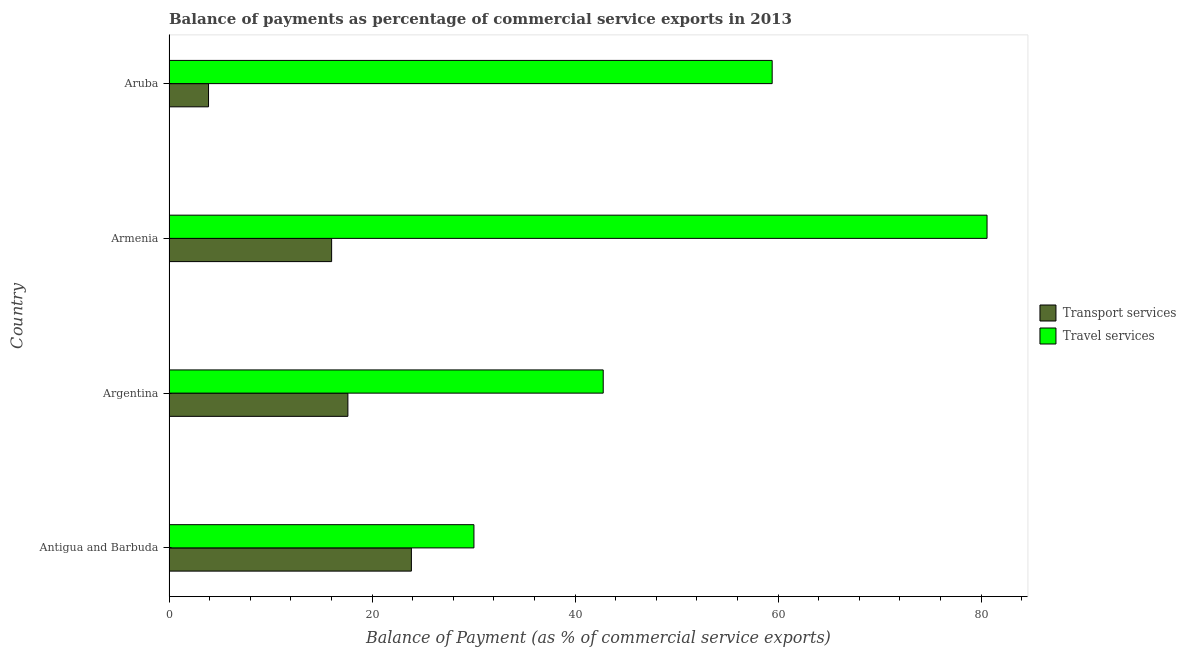Are the number of bars per tick equal to the number of legend labels?
Keep it short and to the point. Yes. Are the number of bars on each tick of the Y-axis equal?
Make the answer very short. Yes. What is the label of the 4th group of bars from the top?
Offer a very short reply. Antigua and Barbuda. What is the balance of payments of travel services in Aruba?
Offer a very short reply. 59.42. Across all countries, what is the maximum balance of payments of travel services?
Offer a terse response. 80.59. Across all countries, what is the minimum balance of payments of transport services?
Your answer should be very brief. 3.89. In which country was the balance of payments of transport services maximum?
Ensure brevity in your answer.  Antigua and Barbuda. In which country was the balance of payments of transport services minimum?
Make the answer very short. Aruba. What is the total balance of payments of travel services in the graph?
Offer a very short reply. 212.82. What is the difference between the balance of payments of travel services in Argentina and that in Aruba?
Provide a succinct answer. -16.64. What is the difference between the balance of payments of travel services in Argentina and the balance of payments of transport services in Armenia?
Provide a short and direct response. 26.75. What is the average balance of payments of travel services per country?
Offer a terse response. 53.2. What is the difference between the balance of payments of travel services and balance of payments of transport services in Antigua and Barbuda?
Give a very brief answer. 6.16. In how many countries, is the balance of payments of transport services greater than 48 %?
Provide a short and direct response. 0. What is the ratio of the balance of payments of transport services in Armenia to that in Aruba?
Provide a succinct answer. 4.11. Is the balance of payments of transport services in Armenia less than that in Aruba?
Give a very brief answer. No. Is the difference between the balance of payments of travel services in Argentina and Armenia greater than the difference between the balance of payments of transport services in Argentina and Armenia?
Make the answer very short. No. What is the difference between the highest and the second highest balance of payments of transport services?
Provide a short and direct response. 6.26. What is the difference between the highest and the lowest balance of payments of travel services?
Your response must be concise. 50.55. What does the 2nd bar from the top in Antigua and Barbuda represents?
Offer a very short reply. Transport services. What does the 2nd bar from the bottom in Aruba represents?
Your answer should be very brief. Travel services. How many bars are there?
Ensure brevity in your answer.  8. What is the difference between two consecutive major ticks on the X-axis?
Provide a short and direct response. 20. Are the values on the major ticks of X-axis written in scientific E-notation?
Provide a short and direct response. No. How are the legend labels stacked?
Provide a succinct answer. Vertical. What is the title of the graph?
Provide a succinct answer. Balance of payments as percentage of commercial service exports in 2013. Does "Birth rate" appear as one of the legend labels in the graph?
Your answer should be very brief. No. What is the label or title of the X-axis?
Keep it short and to the point. Balance of Payment (as % of commercial service exports). What is the label or title of the Y-axis?
Provide a succinct answer. Country. What is the Balance of Payment (as % of commercial service exports) of Transport services in Antigua and Barbuda?
Ensure brevity in your answer.  23.88. What is the Balance of Payment (as % of commercial service exports) of Travel services in Antigua and Barbuda?
Provide a short and direct response. 30.04. What is the Balance of Payment (as % of commercial service exports) in Transport services in Argentina?
Provide a short and direct response. 17.62. What is the Balance of Payment (as % of commercial service exports) in Travel services in Argentina?
Your response must be concise. 42.78. What is the Balance of Payment (as % of commercial service exports) in Transport services in Armenia?
Offer a terse response. 16.02. What is the Balance of Payment (as % of commercial service exports) in Travel services in Armenia?
Ensure brevity in your answer.  80.59. What is the Balance of Payment (as % of commercial service exports) in Transport services in Aruba?
Give a very brief answer. 3.89. What is the Balance of Payment (as % of commercial service exports) of Travel services in Aruba?
Keep it short and to the point. 59.42. Across all countries, what is the maximum Balance of Payment (as % of commercial service exports) of Transport services?
Offer a very short reply. 23.88. Across all countries, what is the maximum Balance of Payment (as % of commercial service exports) of Travel services?
Keep it short and to the point. 80.59. Across all countries, what is the minimum Balance of Payment (as % of commercial service exports) of Transport services?
Give a very brief answer. 3.89. Across all countries, what is the minimum Balance of Payment (as % of commercial service exports) in Travel services?
Offer a very short reply. 30.04. What is the total Balance of Payment (as % of commercial service exports) in Transport services in the graph?
Offer a terse response. 61.42. What is the total Balance of Payment (as % of commercial service exports) in Travel services in the graph?
Provide a succinct answer. 212.82. What is the difference between the Balance of Payment (as % of commercial service exports) of Transport services in Antigua and Barbuda and that in Argentina?
Give a very brief answer. 6.26. What is the difference between the Balance of Payment (as % of commercial service exports) in Travel services in Antigua and Barbuda and that in Argentina?
Give a very brief answer. -12.74. What is the difference between the Balance of Payment (as % of commercial service exports) in Transport services in Antigua and Barbuda and that in Armenia?
Ensure brevity in your answer.  7.86. What is the difference between the Balance of Payment (as % of commercial service exports) in Travel services in Antigua and Barbuda and that in Armenia?
Make the answer very short. -50.55. What is the difference between the Balance of Payment (as % of commercial service exports) in Transport services in Antigua and Barbuda and that in Aruba?
Provide a short and direct response. 19.98. What is the difference between the Balance of Payment (as % of commercial service exports) of Travel services in Antigua and Barbuda and that in Aruba?
Your response must be concise. -29.38. What is the difference between the Balance of Payment (as % of commercial service exports) of Transport services in Argentina and that in Armenia?
Give a very brief answer. 1.6. What is the difference between the Balance of Payment (as % of commercial service exports) of Travel services in Argentina and that in Armenia?
Your answer should be very brief. -37.81. What is the difference between the Balance of Payment (as % of commercial service exports) in Transport services in Argentina and that in Aruba?
Your response must be concise. 13.73. What is the difference between the Balance of Payment (as % of commercial service exports) in Travel services in Argentina and that in Aruba?
Your answer should be very brief. -16.64. What is the difference between the Balance of Payment (as % of commercial service exports) in Transport services in Armenia and that in Aruba?
Ensure brevity in your answer.  12.13. What is the difference between the Balance of Payment (as % of commercial service exports) in Travel services in Armenia and that in Aruba?
Provide a succinct answer. 21.17. What is the difference between the Balance of Payment (as % of commercial service exports) of Transport services in Antigua and Barbuda and the Balance of Payment (as % of commercial service exports) of Travel services in Argentina?
Provide a succinct answer. -18.9. What is the difference between the Balance of Payment (as % of commercial service exports) in Transport services in Antigua and Barbuda and the Balance of Payment (as % of commercial service exports) in Travel services in Armenia?
Your response must be concise. -56.71. What is the difference between the Balance of Payment (as % of commercial service exports) of Transport services in Antigua and Barbuda and the Balance of Payment (as % of commercial service exports) of Travel services in Aruba?
Give a very brief answer. -35.54. What is the difference between the Balance of Payment (as % of commercial service exports) in Transport services in Argentina and the Balance of Payment (as % of commercial service exports) in Travel services in Armenia?
Offer a terse response. -62.96. What is the difference between the Balance of Payment (as % of commercial service exports) in Transport services in Argentina and the Balance of Payment (as % of commercial service exports) in Travel services in Aruba?
Your answer should be very brief. -41.8. What is the difference between the Balance of Payment (as % of commercial service exports) of Transport services in Armenia and the Balance of Payment (as % of commercial service exports) of Travel services in Aruba?
Keep it short and to the point. -43.4. What is the average Balance of Payment (as % of commercial service exports) of Transport services per country?
Offer a very short reply. 15.35. What is the average Balance of Payment (as % of commercial service exports) of Travel services per country?
Offer a very short reply. 53.2. What is the difference between the Balance of Payment (as % of commercial service exports) in Transport services and Balance of Payment (as % of commercial service exports) in Travel services in Antigua and Barbuda?
Your answer should be very brief. -6.16. What is the difference between the Balance of Payment (as % of commercial service exports) in Transport services and Balance of Payment (as % of commercial service exports) in Travel services in Argentina?
Keep it short and to the point. -25.15. What is the difference between the Balance of Payment (as % of commercial service exports) of Transport services and Balance of Payment (as % of commercial service exports) of Travel services in Armenia?
Give a very brief answer. -64.56. What is the difference between the Balance of Payment (as % of commercial service exports) in Transport services and Balance of Payment (as % of commercial service exports) in Travel services in Aruba?
Your answer should be very brief. -55.52. What is the ratio of the Balance of Payment (as % of commercial service exports) in Transport services in Antigua and Barbuda to that in Argentina?
Keep it short and to the point. 1.35. What is the ratio of the Balance of Payment (as % of commercial service exports) in Travel services in Antigua and Barbuda to that in Argentina?
Provide a short and direct response. 0.7. What is the ratio of the Balance of Payment (as % of commercial service exports) in Transport services in Antigua and Barbuda to that in Armenia?
Provide a short and direct response. 1.49. What is the ratio of the Balance of Payment (as % of commercial service exports) in Travel services in Antigua and Barbuda to that in Armenia?
Provide a short and direct response. 0.37. What is the ratio of the Balance of Payment (as % of commercial service exports) in Transport services in Antigua and Barbuda to that in Aruba?
Provide a succinct answer. 6.13. What is the ratio of the Balance of Payment (as % of commercial service exports) of Travel services in Antigua and Barbuda to that in Aruba?
Your answer should be compact. 0.51. What is the ratio of the Balance of Payment (as % of commercial service exports) in Travel services in Argentina to that in Armenia?
Provide a succinct answer. 0.53. What is the ratio of the Balance of Payment (as % of commercial service exports) in Transport services in Argentina to that in Aruba?
Keep it short and to the point. 4.52. What is the ratio of the Balance of Payment (as % of commercial service exports) of Travel services in Argentina to that in Aruba?
Provide a short and direct response. 0.72. What is the ratio of the Balance of Payment (as % of commercial service exports) of Transport services in Armenia to that in Aruba?
Provide a short and direct response. 4.11. What is the ratio of the Balance of Payment (as % of commercial service exports) in Travel services in Armenia to that in Aruba?
Give a very brief answer. 1.36. What is the difference between the highest and the second highest Balance of Payment (as % of commercial service exports) of Transport services?
Your response must be concise. 6.26. What is the difference between the highest and the second highest Balance of Payment (as % of commercial service exports) in Travel services?
Offer a terse response. 21.17. What is the difference between the highest and the lowest Balance of Payment (as % of commercial service exports) of Transport services?
Your response must be concise. 19.98. What is the difference between the highest and the lowest Balance of Payment (as % of commercial service exports) of Travel services?
Keep it short and to the point. 50.55. 